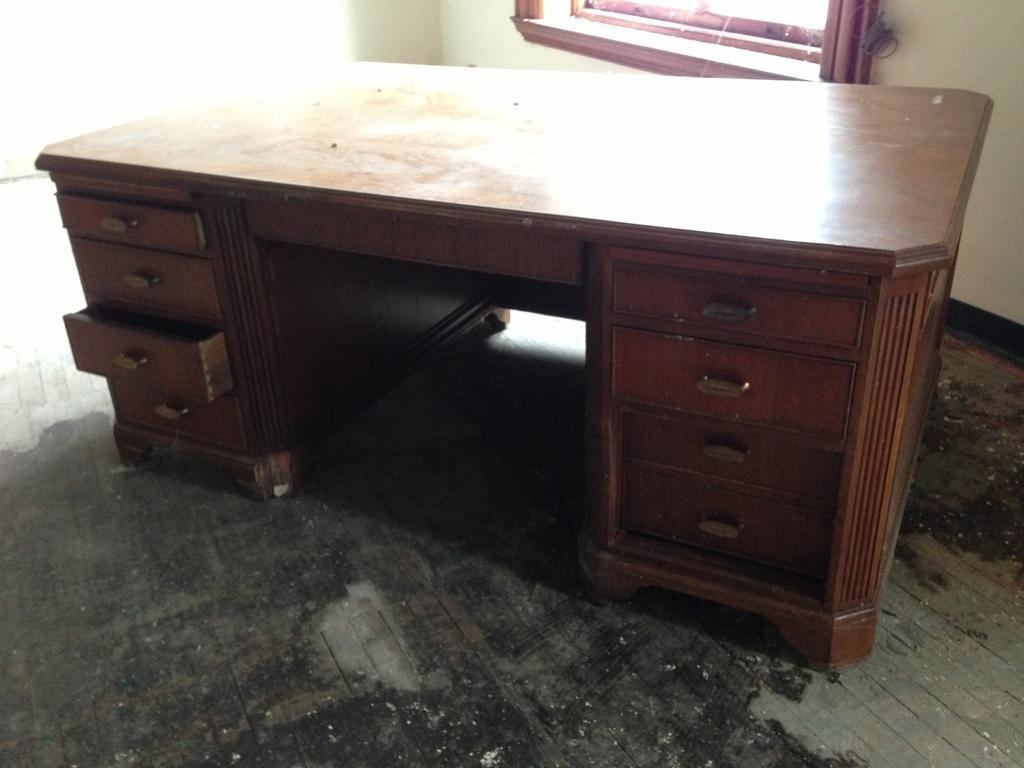What type of furniture is present in the image? There is a table in the image. Where is the table located? The table is on the floor. In which setting is the table located? The table is in a room. What can be seen in the room besides the table? There is a window in the image. What type of linen is draped over the table in the image? There is no linen draped over the table in the image. Can you tell me how much blood is visible on the floor in the image? There is no blood visible on the floor in the image. 